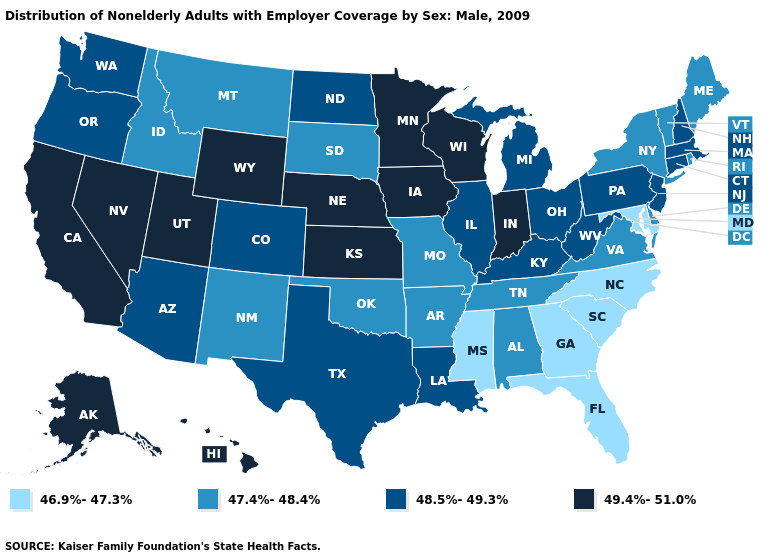Which states have the lowest value in the USA?
Concise answer only. Florida, Georgia, Maryland, Mississippi, North Carolina, South Carolina. Which states hav the highest value in the MidWest?
Quick response, please. Indiana, Iowa, Kansas, Minnesota, Nebraska, Wisconsin. Name the states that have a value in the range 49.4%-51.0%?
Answer briefly. Alaska, California, Hawaii, Indiana, Iowa, Kansas, Minnesota, Nebraska, Nevada, Utah, Wisconsin, Wyoming. What is the lowest value in the USA?
Be succinct. 46.9%-47.3%. Name the states that have a value in the range 47.4%-48.4%?
Answer briefly. Alabama, Arkansas, Delaware, Idaho, Maine, Missouri, Montana, New Mexico, New York, Oklahoma, Rhode Island, South Dakota, Tennessee, Vermont, Virginia. Does New Hampshire have the lowest value in the USA?
Keep it brief. No. Does New York have the highest value in the USA?
Answer briefly. No. What is the highest value in states that border Florida?
Short answer required. 47.4%-48.4%. What is the value of Maine?
Answer briefly. 47.4%-48.4%. Is the legend a continuous bar?
Quick response, please. No. What is the value of Mississippi?
Write a very short answer. 46.9%-47.3%. Does the map have missing data?
Write a very short answer. No. Name the states that have a value in the range 46.9%-47.3%?
Answer briefly. Florida, Georgia, Maryland, Mississippi, North Carolina, South Carolina. What is the value of New Hampshire?
Short answer required. 48.5%-49.3%. Name the states that have a value in the range 46.9%-47.3%?
Write a very short answer. Florida, Georgia, Maryland, Mississippi, North Carolina, South Carolina. 